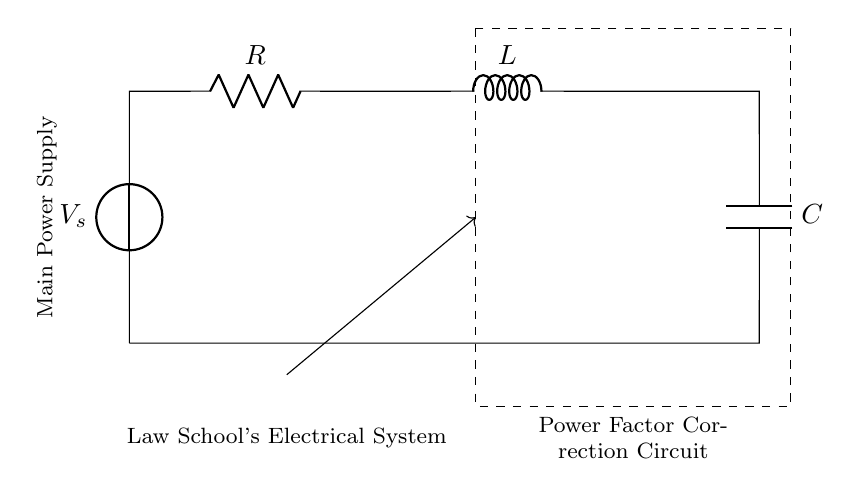What is the main component in this circuit? The main component is the power supply, which is represented as a voltage source labeled V_s.
Answer: voltage source What type of circuit is depicted here? The circuit depicted is a Power Factor Correction Circuit, which includes resistive, inductive, and capacitive elements.
Answer: Power Factor Correction Circuit What components are included in this circuit? The components included are a resistor, an inductor, and a capacitor, identified by their respective symbols in the diagram.
Answer: resistor, inductor, capacitor What is the purpose of a power factor correction circuit in this context? The purpose is to improve the power factor of the law school's electrical system, thereby optimizing the efficiency of power consumption.
Answer: improve power factor How does the RLC arrangement affect the circuit's power factor? The arrangement of the resistor, inductor, and capacitor creates a circuit that can mitigate reactive power, ultimately improving the power factor.
Answer: mitigates reactive power What is the overall effect of adding a capacitor in this circuit? Adding a capacitor helps to counteract the inductive reactance, which enhances the power factor, leading to more efficient power usage.
Answer: enhances power factor 